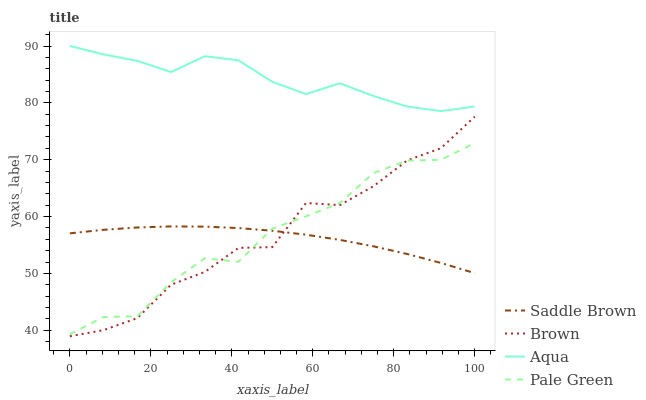Does Saddle Brown have the minimum area under the curve?
Answer yes or no. Yes. Does Aqua have the maximum area under the curve?
Answer yes or no. Yes. Does Pale Green have the minimum area under the curve?
Answer yes or no. No. Does Pale Green have the maximum area under the curve?
Answer yes or no. No. Is Saddle Brown the smoothest?
Answer yes or no. Yes. Is Brown the roughest?
Answer yes or no. Yes. Is Pale Green the smoothest?
Answer yes or no. No. Is Pale Green the roughest?
Answer yes or no. No. Does Brown have the lowest value?
Answer yes or no. Yes. Does Pale Green have the lowest value?
Answer yes or no. No. Does Aqua have the highest value?
Answer yes or no. Yes. Does Pale Green have the highest value?
Answer yes or no. No. Is Pale Green less than Aqua?
Answer yes or no. Yes. Is Aqua greater than Brown?
Answer yes or no. Yes. Does Pale Green intersect Saddle Brown?
Answer yes or no. Yes. Is Pale Green less than Saddle Brown?
Answer yes or no. No. Is Pale Green greater than Saddle Brown?
Answer yes or no. No. Does Pale Green intersect Aqua?
Answer yes or no. No. 